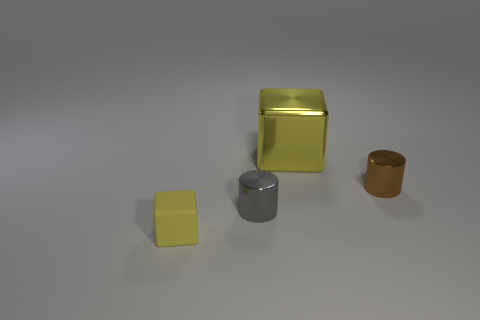What is the material of the big block that is the same color as the tiny matte object?
Keep it short and to the point. Metal. There is a cube that is on the left side of the small metal cylinder in front of the small cylinder right of the yellow shiny block; what color is it?
Offer a very short reply. Yellow. Is the color of the cube that is in front of the tiny brown metal thing the same as the metallic cylinder right of the large yellow metallic block?
Ensure brevity in your answer.  No. How many matte objects are in front of the cylinder in front of the small brown object?
Make the answer very short. 1. Is there a tiny gray metallic thing?
Give a very brief answer. Yes. How many other things are the same color as the big cube?
Provide a short and direct response. 1. Is the number of brown metal objects less than the number of big purple metal blocks?
Keep it short and to the point. No. What is the shape of the tiny shiny thing that is to the left of the cube that is to the right of the tiny cube?
Make the answer very short. Cylinder. Are there any small metal objects to the right of the large shiny cube?
Make the answer very short. Yes. There is another matte object that is the same size as the brown object; what color is it?
Provide a short and direct response. Yellow. 